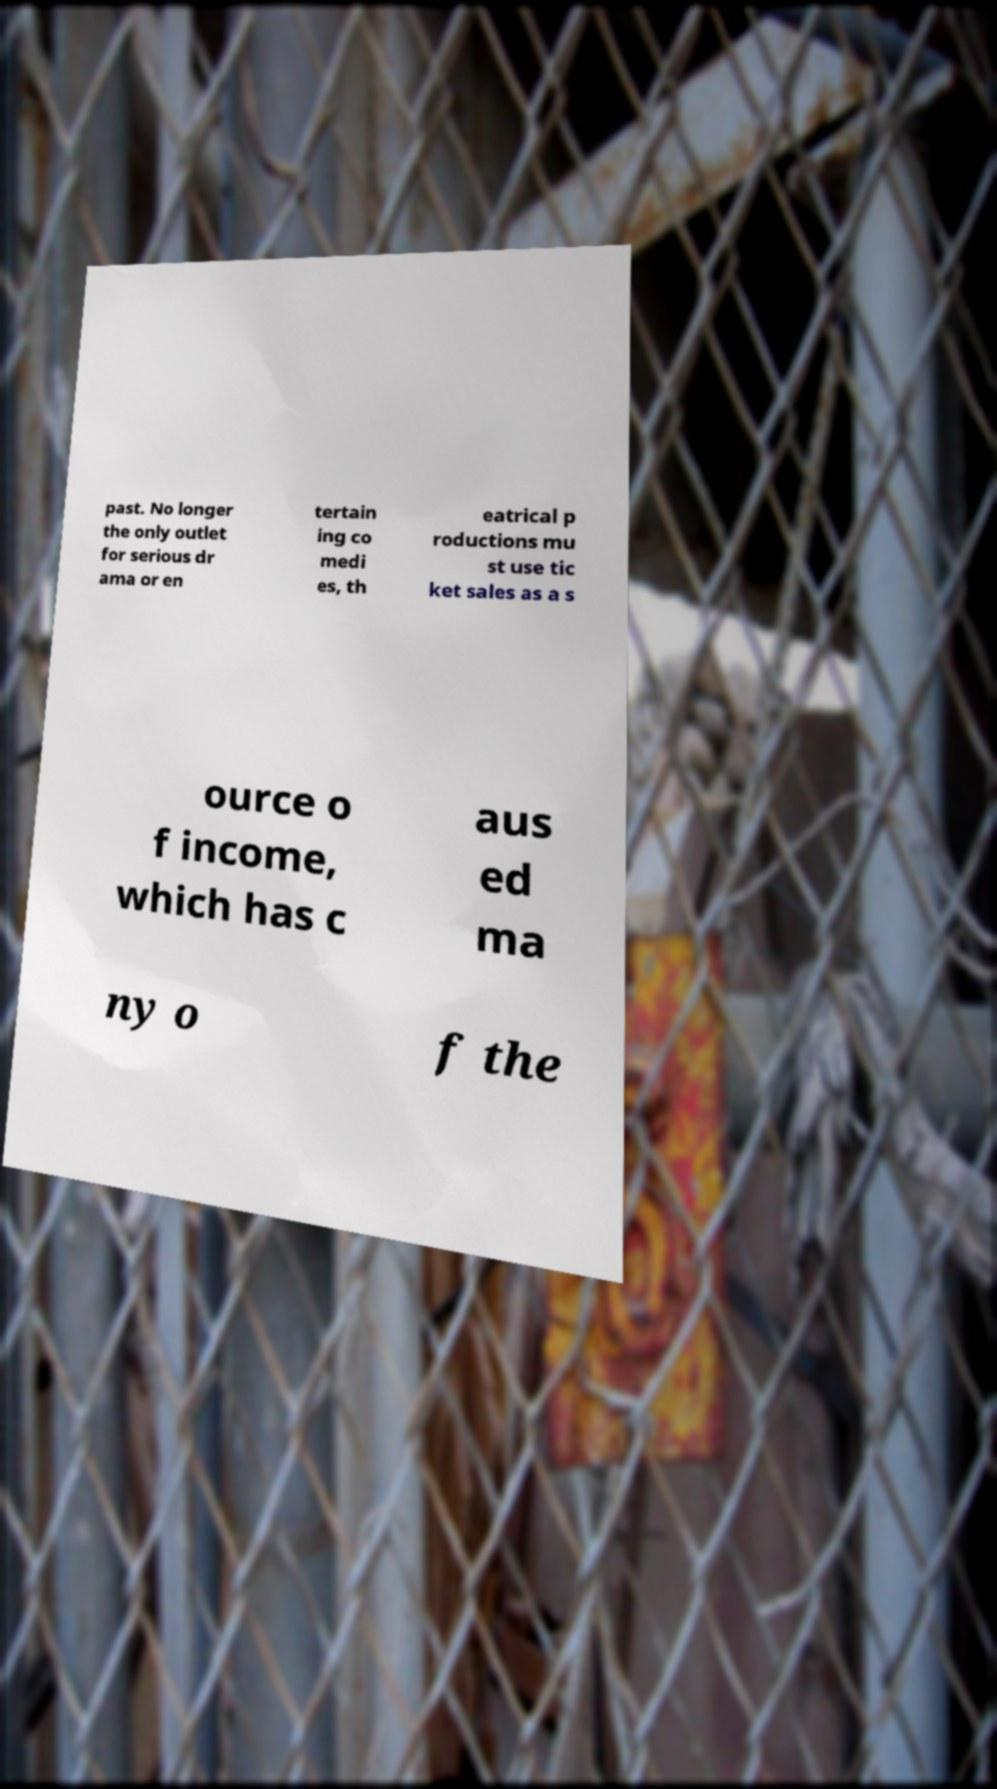Could you extract and type out the text from this image? past. No longer the only outlet for serious dr ama or en tertain ing co medi es, th eatrical p roductions mu st use tic ket sales as a s ource o f income, which has c aus ed ma ny o f the 